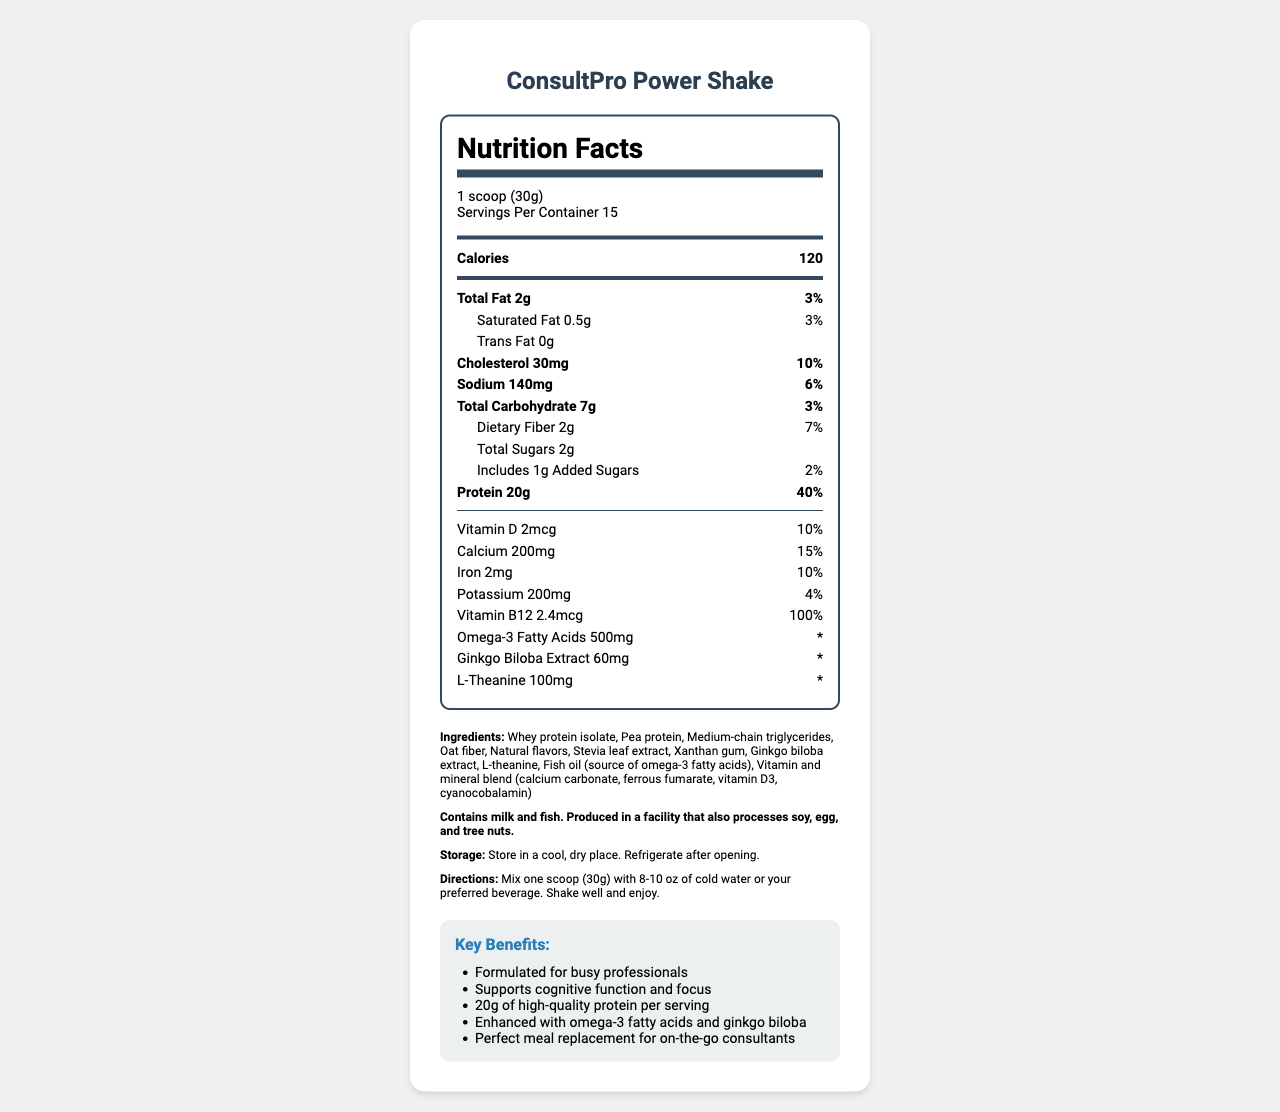who is the intended customer for the ConsultPro Power Shake? The document states that the protein shake is designed for busy professionals, particularly consultants.
Answer: Busy consultants what is the protein content per serving? The Nutrition Facts section lists 20g of protein per serving.
Answer: 20g how many servings are in one container? The serving information indicates that there are 15 servings per container.
Answer: 15 servings what percentage of the daily value for Vitamin B12 does one serving provide? The Nutrition Facts section shows that one serving provides 100% of the daily value for Vitamin B12.
Answer: 100% which ingredients in the ConsultPro Power Shake are mentioned as supporting cognitive function? The document highlights that Ginkgo Biloba Extract and L-Theanine are ingredients known for supporting cognitive function.
Answer: Ginkgo Biloba Extract and L-Theanine how many calories are in one scoop (30g) of the ConsultPro Power Shake? The Nutrition Facts section indicates that one serving of 30g has 120 calories.
Answer: 120 calories what is the total fat content in one serving? The Nutrition Facts list shows that one serving contains 2g of total fat.
Answer: 2g how should the ConsultPro Power Shake be mixed for optimal enjoyment? The directions specify to mix one scoop with 8-10 oz of cold water or your preferred beverage and shake well.
Answer: Mix one scoop (30g) with 8-10 oz of cold water or your preferred beverage. Shake well and enjoy. what are the main allergens mentioned in the ConsultPro Power Shake? The allergen information states that the product contains milk and fish.
Answer: Milk and fish which of the following is NOT included in the ConsultPro Power Shake's ingredients? A. Whey protein isolate B. Soy protein C. Pea protein D. Stevia leaf extract The ingredients list does not include soy protein.
Answer: B. Soy protein what percentage of the daily value for sodium is provided by one serving? The Nutrition Facts section states that one serving provides 6% of the daily value for sodium.
Answer: 6% True or False: The ConsultPro Power Shake contains trans fat. The Nutrition Facts section shows that the trans fat content is 0g.
Answer: False give a brief summary of the ConsultPro Power Shake and its key benefits. The document gives an overview of the product, its nutritional content, ingredients, and the marketed benefits, emphasizing its suitability for busy professionals.
Answer: The ConsultPro Power Shake is a protein shake designed for busy consultants. It contains 20g of protein per serving and includes ingredients that support cognitive function, such as Ginkgo Biloba Extract and L-Theanine. It is also enriched with omega-3 fatty acids and vitamins. It serves as a convenient meal replacement with added benefits for focus and cognitive support. how much added sugar does one serving of ConsultPro Power Shake contain? The Nutrition Facts section states that there is 1g of added sugar per serving.
Answer: 1g in what kind of facility is the ConsultPro Power Shake produced? The allergen information mentions that the product is made in a facility that processes soy, egg, and tree nuts.
Answer: A facility that also processes soy, egg, and tree nuts. how should the ConsultPro Power Shake be stored after opening? The storage instructions specify to refrigerate the product after opening.
Answer: Refrigerate after opening what is the daily value percentage of calcium provided by one serving? The Nutrition Facts section lists that one serving provides 15% of the daily value for calcium.
Answer: 15% what are the natural flavors mentioned in the list of ingredients? The document lists "natural flavors," but it does not specify what those natural flavors are.
Answer: Cannot be determined 